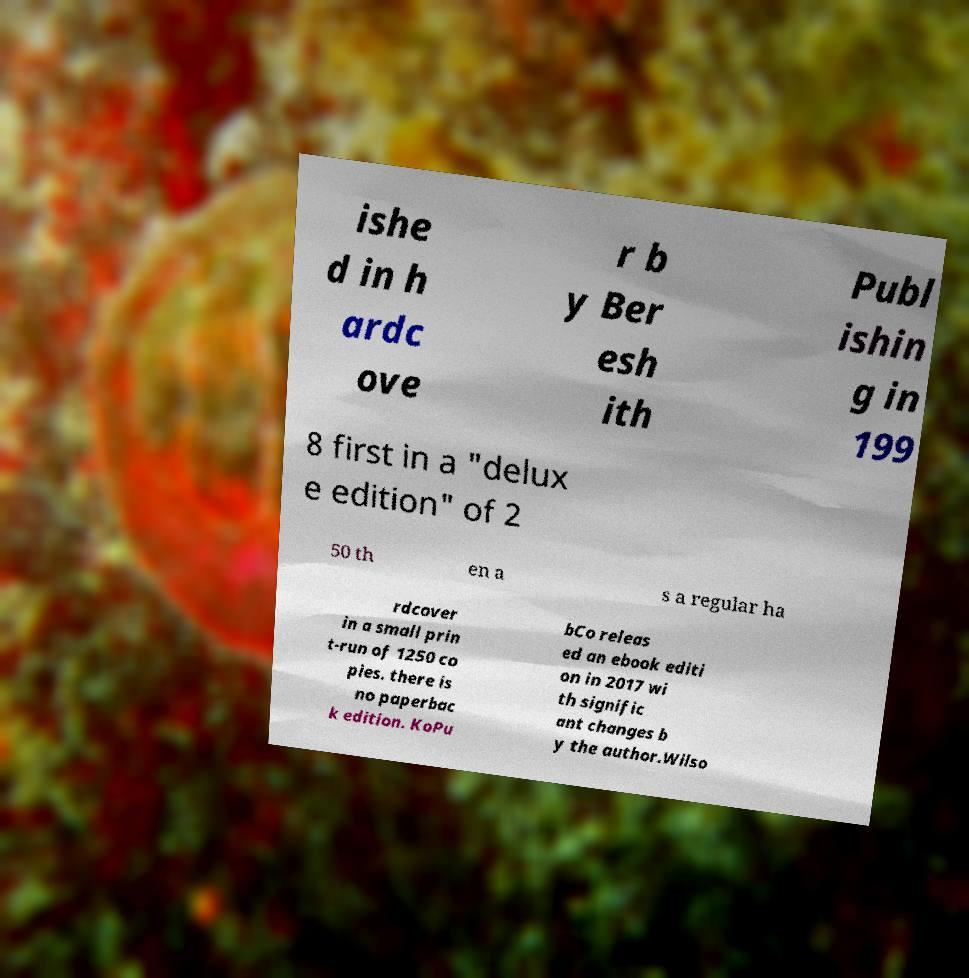Can you accurately transcribe the text from the provided image for me? ishe d in h ardc ove r b y Ber esh ith Publ ishin g in 199 8 first in a "delux e edition" of 2 50 th en a s a regular ha rdcover in a small prin t-run of 1250 co pies. there is no paperbac k edition. KoPu bCo releas ed an ebook editi on in 2017 wi th signific ant changes b y the author.Wilso 